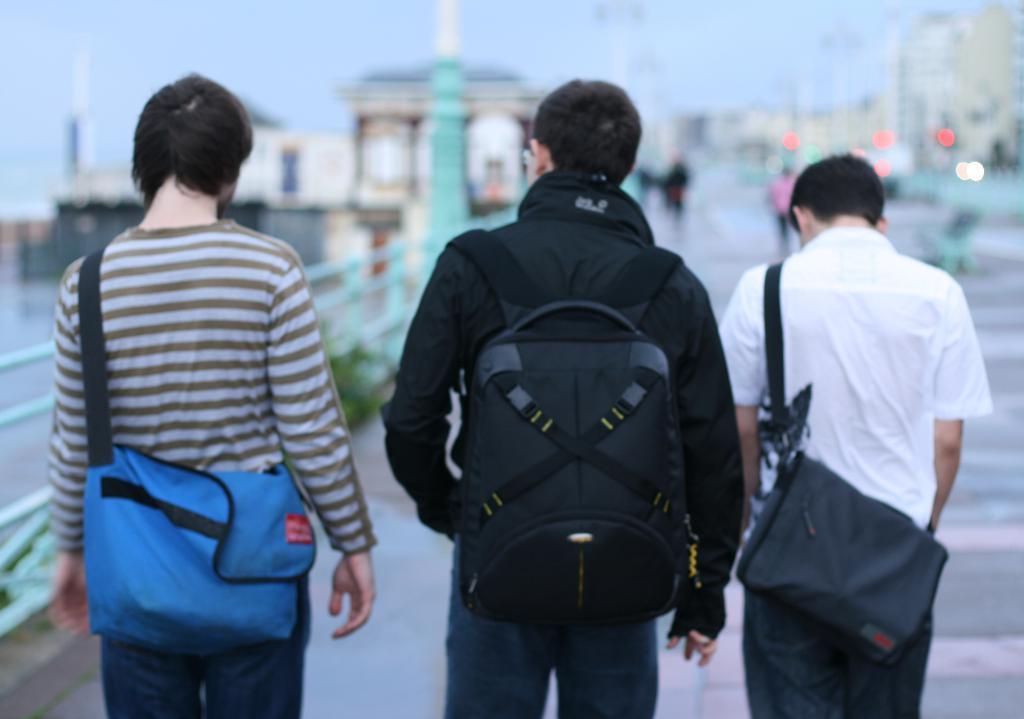Can you describe this image briefly? In this image I see 3 men and all of them are carrying a bag. I see people and the path which is blurred. 